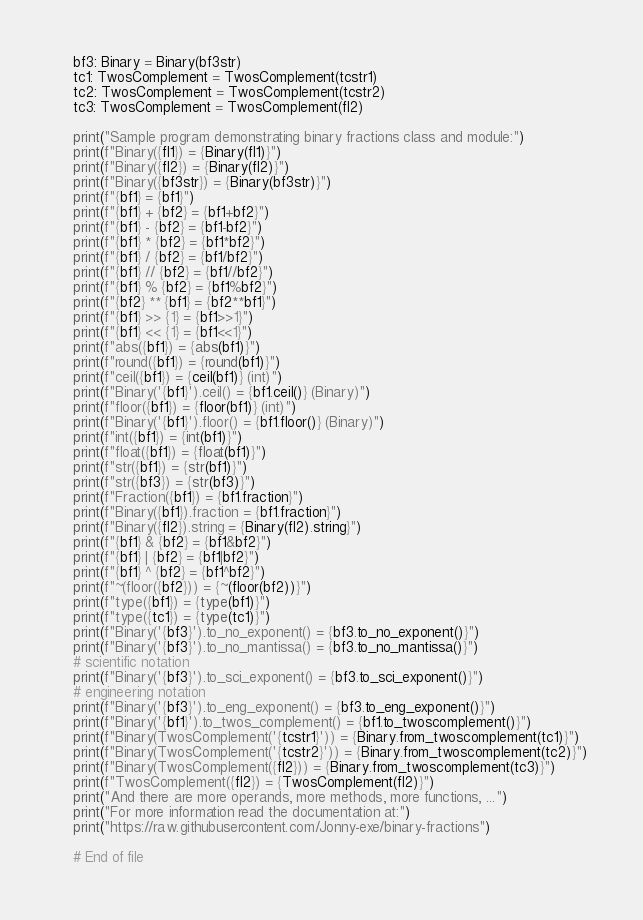Convert code to text. <code><loc_0><loc_0><loc_500><loc_500><_Python_>    bf3: Binary = Binary(bf3str)
    tc1: TwosComplement = TwosComplement(tcstr1)
    tc2: TwosComplement = TwosComplement(tcstr2)
    tc3: TwosComplement = TwosComplement(fl2)

    print("Sample program demonstrating binary fractions class and module:")
    print(f"Binary({fl1}) = {Binary(fl1)}")
    print(f"Binary({fl2}) = {Binary(fl2)}")
    print(f"Binary({bf3str}) = {Binary(bf3str)}")
    print(f"{bf1} = {bf1}")
    print(f"{bf1} + {bf2} = {bf1+bf2}")
    print(f"{bf1} - {bf2} = {bf1-bf2}")
    print(f"{bf1} * {bf2} = {bf1*bf2}")
    print(f"{bf1} / {bf2} = {bf1/bf2}")
    print(f"{bf1} // {bf2} = {bf1//bf2}")
    print(f"{bf1} % {bf2} = {bf1%bf2}")
    print(f"{bf2} ** {bf1} = {bf2**bf1}")
    print(f"{bf1} >> {1} = {bf1>>1}")
    print(f"{bf1} << {1} = {bf1<<1}")
    print(f"abs({bf1}) = {abs(bf1)}")
    print(f"round({bf1}) = {round(bf1)}")
    print(f"ceil({bf1}) = {ceil(bf1)} (int)")
    print(f"Binary('{bf1}').ceil() = {bf1.ceil()} (Binary)")
    print(f"floor({bf1}) = {floor(bf1)} (int)")
    print(f"Binary('{bf1}').floor() = {bf1.floor()} (Binary)")
    print(f"int({bf1}) = {int(bf1)}")
    print(f"float({bf1}) = {float(bf1)}")
    print(f"str({bf1}) = {str(bf1)}")
    print(f"str({bf3}) = {str(bf3)}")
    print(f"Fraction({bf1}) = {bf1.fraction}")
    print(f"Binary({bf1}).fraction = {bf1.fraction}")
    print(f"Binary({fl2}).string = {Binary(fl2).string}")
    print(f"{bf1} & {bf2} = {bf1&bf2}")
    print(f"{bf1} | {bf2} = {bf1|bf2}")
    print(f"{bf1} ^ {bf2} = {bf1^bf2}")
    print(f"~(floor({bf2})) = {~(floor(bf2))}")
    print(f"type({bf1}) = {type(bf1)}")
    print(f"type({tc1}) = {type(tc1)}")
    print(f"Binary('{bf3}').to_no_exponent() = {bf3.to_no_exponent()}")
    print(f"Binary('{bf3}').to_no_mantissa() = {bf3.to_no_mantissa()}")
    # scientific notation
    print(f"Binary('{bf3}').to_sci_exponent() = {bf3.to_sci_exponent()}")
    # engineering notation
    print(f"Binary('{bf3}').to_eng_exponent() = {bf3.to_eng_exponent()}")
    print(f"Binary('{bf1}').to_twos_complement() = {bf1.to_twoscomplement()}")
    print(f"Binary(TwosComplement('{tcstr1}')) = {Binary.from_twoscomplement(tc1)}")
    print(f"Binary(TwosComplement('{tcstr2}')) = {Binary.from_twoscomplement(tc2)}")
    print(f"Binary(TwosComplement({fl2})) = {Binary.from_twoscomplement(tc3)}")
    print(f"TwosComplement({fl2}) = {TwosComplement(fl2)}")
    print("And there are more operands, more methods, more functions, ...")
    print("For more information read the documentation at:")
    print("https://raw.githubusercontent.com/Jonny-exe/binary-fractions")

    # End of file
</code> 